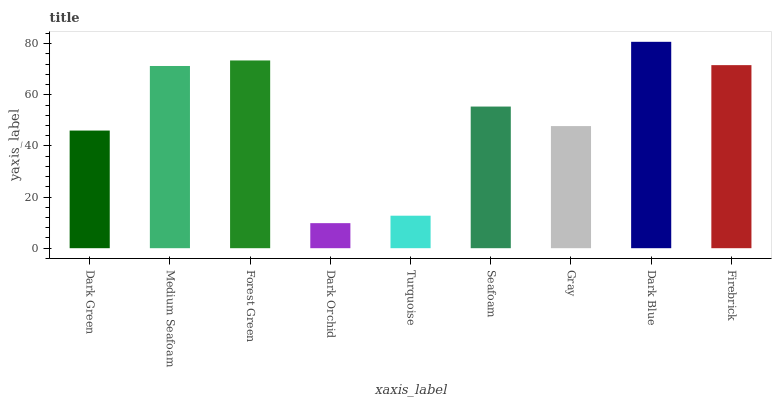Is Medium Seafoam the minimum?
Answer yes or no. No. Is Medium Seafoam the maximum?
Answer yes or no. No. Is Medium Seafoam greater than Dark Green?
Answer yes or no. Yes. Is Dark Green less than Medium Seafoam?
Answer yes or no. Yes. Is Dark Green greater than Medium Seafoam?
Answer yes or no. No. Is Medium Seafoam less than Dark Green?
Answer yes or no. No. Is Seafoam the high median?
Answer yes or no. Yes. Is Seafoam the low median?
Answer yes or no. Yes. Is Forest Green the high median?
Answer yes or no. No. Is Dark Green the low median?
Answer yes or no. No. 